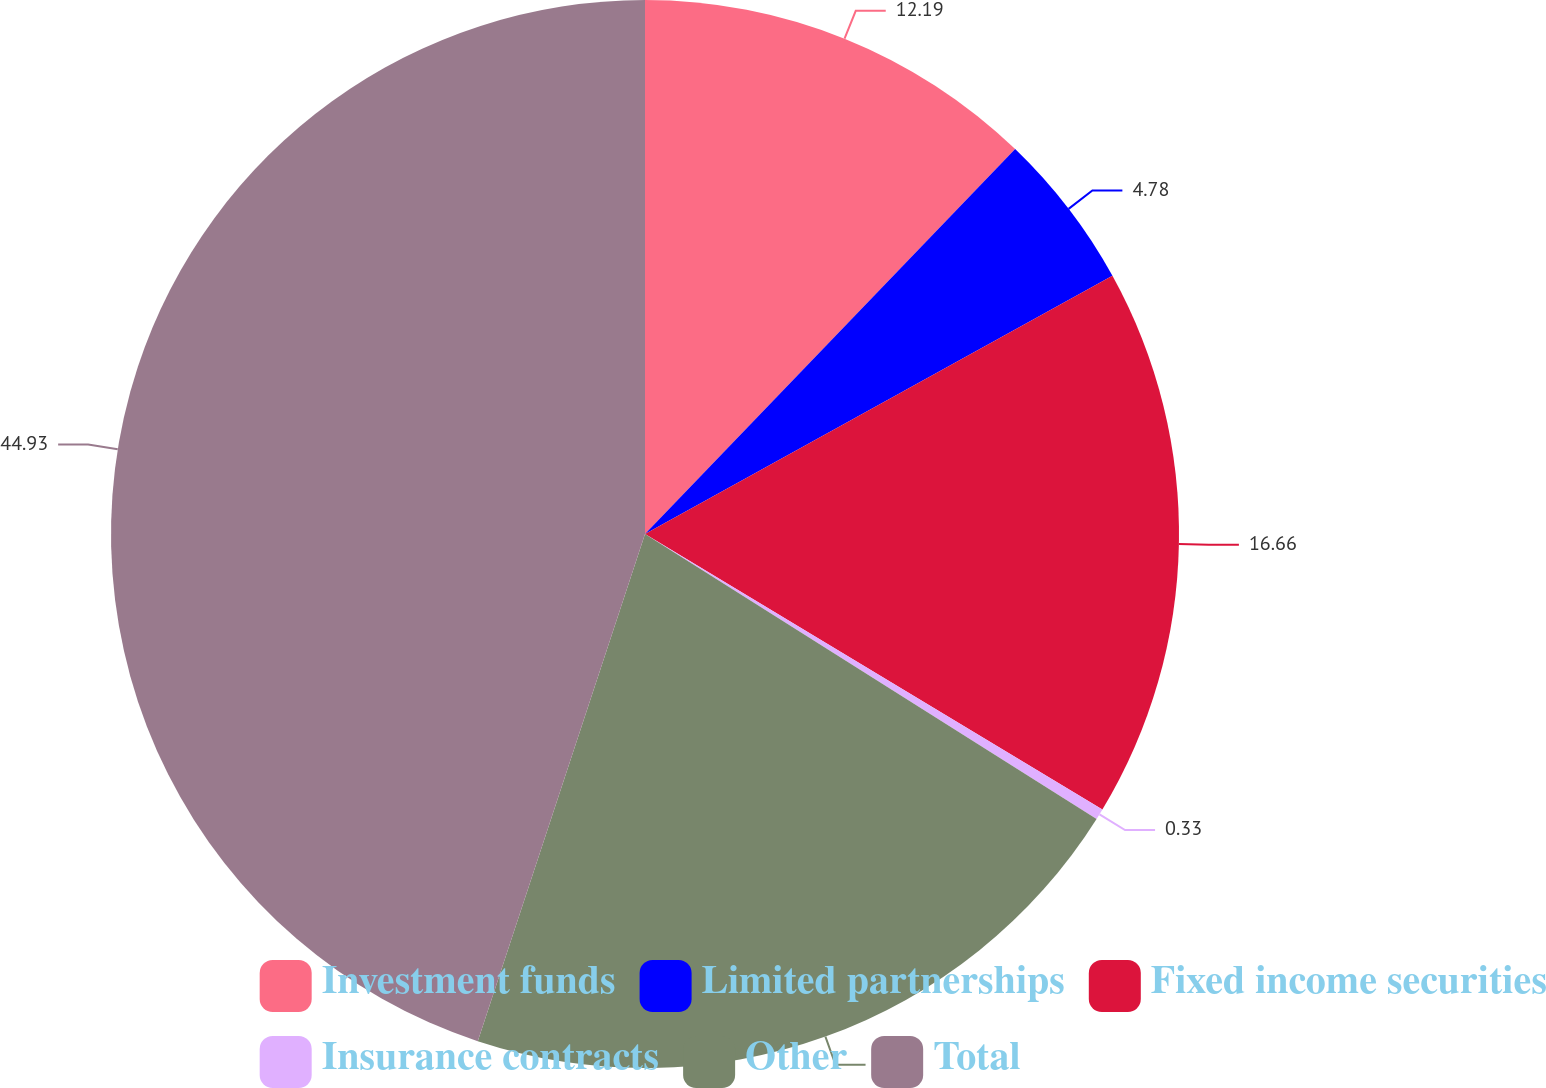Convert chart to OTSL. <chart><loc_0><loc_0><loc_500><loc_500><pie_chart><fcel>Investment funds<fcel>Limited partnerships<fcel>Fixed income securities<fcel>Insurance contracts<fcel>Other<fcel>Total<nl><fcel>12.19%<fcel>4.78%<fcel>16.66%<fcel>0.33%<fcel>21.11%<fcel>44.93%<nl></chart> 